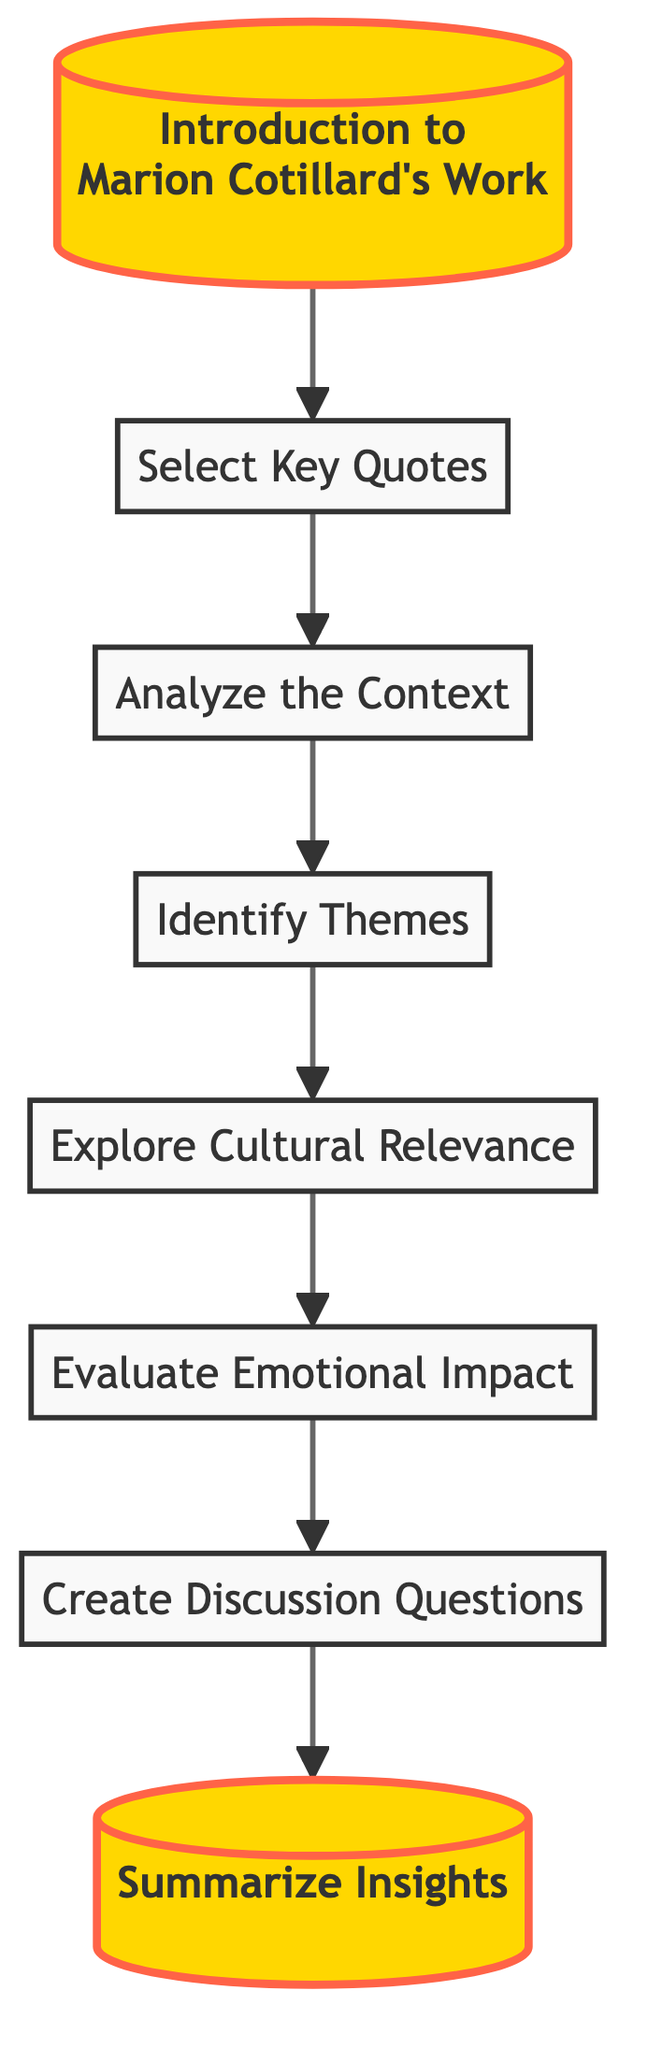What is the first step in the flow chart? The first step is labeled "Introduction to Marion Cotillard's Work," which starts the flowchart. It provides an overview of her filmography and impact on cinema.
Answer: Introduction to Marion Cotillard's Work How many nodes are there in the diagram? By counting all the labeled boxes in the flow chart, we find there are eight nodes total.
Answer: Eight What is the last step in the flow chart? The last step is labeled "Summarize Insights," which concludes the analysis process.
Answer: Summarize Insights What is the relationship between "Select Key Quotes" and "Analyze the Context"? "Select Key Quotes" flows directly into "Analyze the Context," indicating that selecting quotes is necessary before analyzing their context.
Answer: Direct flow Which two nodes deal with emotional aspects of the quotes? "Evaluate Emotional Impact" and "Create Discussion Questions" both focus on the emotional significance of the quotes.
Answer: Evaluate Emotional Impact, Create Discussion Questions Describe the theme present after analyzing the context. The theme identified after "Analyze the Context" is explored in the node "Identify Themes," which reveals the main ideas conveyed in the quotes.
Answer: Identify Themes What is the color coding for the "Analyze the Context" node? The node "Analyze the Context" is filled with light blue color (#e6f3ff) and outlined in a darker blue (#4a86e8).
Answer: Light blue What is the purpose of the "Explore Cultural Relevance" node in the analysis? The node discusses the resonance of the quotes with French culture and cinema, making it an essential part of understanding their significance.
Answer: Discuss resonance with French culture 